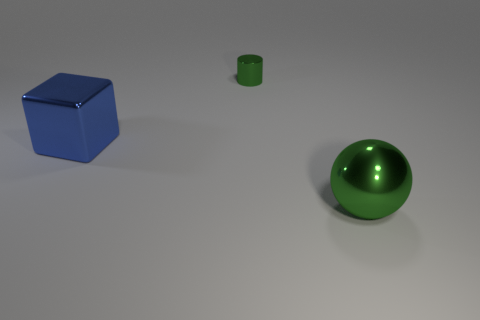Add 2 gray metal cylinders. How many objects exist? 5 Add 1 blue blocks. How many blue blocks are left? 2 Add 1 large spheres. How many large spheres exist? 2 Subtract 1 blue blocks. How many objects are left? 2 Subtract all large red blocks. Subtract all large objects. How many objects are left? 1 